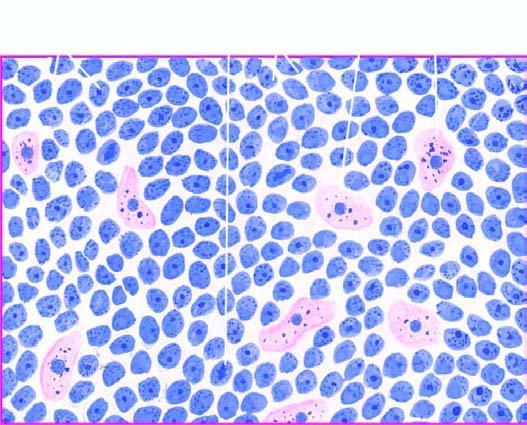does the margin of infracted area show uniform cells having high mitotic rate?
Answer the question using a single word or phrase. No 